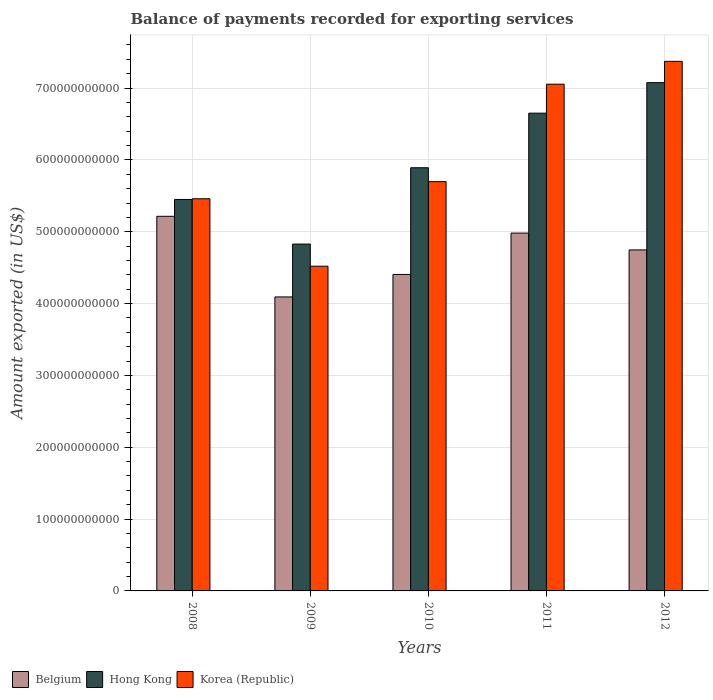How many different coloured bars are there?
Make the answer very short. 3. Are the number of bars on each tick of the X-axis equal?
Your answer should be very brief. Yes. How many bars are there on the 3rd tick from the right?
Give a very brief answer. 3. In how many cases, is the number of bars for a given year not equal to the number of legend labels?
Offer a very short reply. 0. What is the amount exported in Korea (Republic) in 2008?
Your answer should be compact. 5.46e+11. Across all years, what is the maximum amount exported in Belgium?
Provide a short and direct response. 5.21e+11. Across all years, what is the minimum amount exported in Korea (Republic)?
Provide a succinct answer. 4.52e+11. In which year was the amount exported in Belgium maximum?
Offer a terse response. 2008. What is the total amount exported in Korea (Republic) in the graph?
Offer a terse response. 3.01e+12. What is the difference between the amount exported in Hong Kong in 2009 and that in 2010?
Your answer should be compact. -1.06e+11. What is the difference between the amount exported in Hong Kong in 2011 and the amount exported in Korea (Republic) in 2012?
Provide a succinct answer. -7.21e+1. What is the average amount exported in Hong Kong per year?
Your answer should be very brief. 5.98e+11. In the year 2012, what is the difference between the amount exported in Belgium and amount exported in Hong Kong?
Keep it short and to the point. -2.33e+11. What is the ratio of the amount exported in Korea (Republic) in 2008 to that in 2010?
Provide a succinct answer. 0.96. What is the difference between the highest and the second highest amount exported in Korea (Republic)?
Provide a succinct answer. 3.18e+1. What is the difference between the highest and the lowest amount exported in Belgium?
Ensure brevity in your answer.  1.12e+11. What does the 1st bar from the right in 2009 represents?
Your response must be concise. Korea (Republic). Are all the bars in the graph horizontal?
Your answer should be very brief. No. What is the difference between two consecutive major ticks on the Y-axis?
Offer a very short reply. 1.00e+11. Does the graph contain any zero values?
Your answer should be compact. No. Where does the legend appear in the graph?
Ensure brevity in your answer.  Bottom left. What is the title of the graph?
Your answer should be compact. Balance of payments recorded for exporting services. Does "South Asia" appear as one of the legend labels in the graph?
Provide a short and direct response. No. What is the label or title of the Y-axis?
Your answer should be compact. Amount exported (in US$). What is the Amount exported (in US$) of Belgium in 2008?
Your response must be concise. 5.21e+11. What is the Amount exported (in US$) in Hong Kong in 2008?
Offer a very short reply. 5.45e+11. What is the Amount exported (in US$) in Korea (Republic) in 2008?
Make the answer very short. 5.46e+11. What is the Amount exported (in US$) of Belgium in 2009?
Your answer should be very brief. 4.09e+11. What is the Amount exported (in US$) in Hong Kong in 2009?
Provide a succinct answer. 4.83e+11. What is the Amount exported (in US$) in Korea (Republic) in 2009?
Offer a terse response. 4.52e+11. What is the Amount exported (in US$) in Belgium in 2010?
Your response must be concise. 4.41e+11. What is the Amount exported (in US$) of Hong Kong in 2010?
Ensure brevity in your answer.  5.89e+11. What is the Amount exported (in US$) in Korea (Republic) in 2010?
Ensure brevity in your answer.  5.70e+11. What is the Amount exported (in US$) of Belgium in 2011?
Keep it short and to the point. 4.98e+11. What is the Amount exported (in US$) in Hong Kong in 2011?
Your answer should be very brief. 6.65e+11. What is the Amount exported (in US$) in Korea (Republic) in 2011?
Provide a short and direct response. 7.05e+11. What is the Amount exported (in US$) of Belgium in 2012?
Offer a terse response. 4.75e+11. What is the Amount exported (in US$) of Hong Kong in 2012?
Your response must be concise. 7.08e+11. What is the Amount exported (in US$) of Korea (Republic) in 2012?
Provide a succinct answer. 7.37e+11. Across all years, what is the maximum Amount exported (in US$) of Belgium?
Your answer should be compact. 5.21e+11. Across all years, what is the maximum Amount exported (in US$) of Hong Kong?
Provide a short and direct response. 7.08e+11. Across all years, what is the maximum Amount exported (in US$) of Korea (Republic)?
Make the answer very short. 7.37e+11. Across all years, what is the minimum Amount exported (in US$) in Belgium?
Make the answer very short. 4.09e+11. Across all years, what is the minimum Amount exported (in US$) of Hong Kong?
Your answer should be very brief. 4.83e+11. Across all years, what is the minimum Amount exported (in US$) of Korea (Republic)?
Offer a terse response. 4.52e+11. What is the total Amount exported (in US$) of Belgium in the graph?
Give a very brief answer. 2.34e+12. What is the total Amount exported (in US$) in Hong Kong in the graph?
Your answer should be compact. 2.99e+12. What is the total Amount exported (in US$) of Korea (Republic) in the graph?
Offer a terse response. 3.01e+12. What is the difference between the Amount exported (in US$) of Belgium in 2008 and that in 2009?
Your answer should be very brief. 1.12e+11. What is the difference between the Amount exported (in US$) in Hong Kong in 2008 and that in 2009?
Ensure brevity in your answer.  6.21e+1. What is the difference between the Amount exported (in US$) in Korea (Republic) in 2008 and that in 2009?
Your answer should be compact. 9.39e+1. What is the difference between the Amount exported (in US$) of Belgium in 2008 and that in 2010?
Your answer should be compact. 8.09e+1. What is the difference between the Amount exported (in US$) in Hong Kong in 2008 and that in 2010?
Provide a short and direct response. -4.42e+1. What is the difference between the Amount exported (in US$) of Korea (Republic) in 2008 and that in 2010?
Provide a succinct answer. -2.39e+1. What is the difference between the Amount exported (in US$) in Belgium in 2008 and that in 2011?
Provide a short and direct response. 2.33e+1. What is the difference between the Amount exported (in US$) of Hong Kong in 2008 and that in 2011?
Your answer should be very brief. -1.20e+11. What is the difference between the Amount exported (in US$) in Korea (Republic) in 2008 and that in 2011?
Offer a terse response. -1.60e+11. What is the difference between the Amount exported (in US$) in Belgium in 2008 and that in 2012?
Your response must be concise. 4.68e+1. What is the difference between the Amount exported (in US$) in Hong Kong in 2008 and that in 2012?
Keep it short and to the point. -1.63e+11. What is the difference between the Amount exported (in US$) of Korea (Republic) in 2008 and that in 2012?
Your answer should be very brief. -1.91e+11. What is the difference between the Amount exported (in US$) in Belgium in 2009 and that in 2010?
Provide a short and direct response. -3.13e+1. What is the difference between the Amount exported (in US$) of Hong Kong in 2009 and that in 2010?
Provide a succinct answer. -1.06e+11. What is the difference between the Amount exported (in US$) of Korea (Republic) in 2009 and that in 2010?
Offer a very short reply. -1.18e+11. What is the difference between the Amount exported (in US$) of Belgium in 2009 and that in 2011?
Provide a short and direct response. -8.89e+1. What is the difference between the Amount exported (in US$) in Hong Kong in 2009 and that in 2011?
Ensure brevity in your answer.  -1.82e+11. What is the difference between the Amount exported (in US$) of Korea (Republic) in 2009 and that in 2011?
Make the answer very short. -2.53e+11. What is the difference between the Amount exported (in US$) of Belgium in 2009 and that in 2012?
Make the answer very short. -6.54e+1. What is the difference between the Amount exported (in US$) in Hong Kong in 2009 and that in 2012?
Make the answer very short. -2.25e+11. What is the difference between the Amount exported (in US$) of Korea (Republic) in 2009 and that in 2012?
Make the answer very short. -2.85e+11. What is the difference between the Amount exported (in US$) in Belgium in 2010 and that in 2011?
Your answer should be compact. -5.76e+1. What is the difference between the Amount exported (in US$) in Hong Kong in 2010 and that in 2011?
Make the answer very short. -7.60e+1. What is the difference between the Amount exported (in US$) in Korea (Republic) in 2010 and that in 2011?
Ensure brevity in your answer.  -1.36e+11. What is the difference between the Amount exported (in US$) in Belgium in 2010 and that in 2012?
Your answer should be compact. -3.41e+1. What is the difference between the Amount exported (in US$) in Hong Kong in 2010 and that in 2012?
Your answer should be compact. -1.18e+11. What is the difference between the Amount exported (in US$) of Korea (Republic) in 2010 and that in 2012?
Offer a very short reply. -1.67e+11. What is the difference between the Amount exported (in US$) of Belgium in 2011 and that in 2012?
Ensure brevity in your answer.  2.34e+1. What is the difference between the Amount exported (in US$) in Hong Kong in 2011 and that in 2012?
Make the answer very short. -4.25e+1. What is the difference between the Amount exported (in US$) in Korea (Republic) in 2011 and that in 2012?
Provide a short and direct response. -3.18e+1. What is the difference between the Amount exported (in US$) of Belgium in 2008 and the Amount exported (in US$) of Hong Kong in 2009?
Provide a succinct answer. 3.86e+1. What is the difference between the Amount exported (in US$) of Belgium in 2008 and the Amount exported (in US$) of Korea (Republic) in 2009?
Ensure brevity in your answer.  6.95e+1. What is the difference between the Amount exported (in US$) of Hong Kong in 2008 and the Amount exported (in US$) of Korea (Republic) in 2009?
Make the answer very short. 9.29e+1. What is the difference between the Amount exported (in US$) in Belgium in 2008 and the Amount exported (in US$) in Hong Kong in 2010?
Offer a very short reply. -6.76e+1. What is the difference between the Amount exported (in US$) in Belgium in 2008 and the Amount exported (in US$) in Korea (Republic) in 2010?
Provide a short and direct response. -4.83e+1. What is the difference between the Amount exported (in US$) of Hong Kong in 2008 and the Amount exported (in US$) of Korea (Republic) in 2010?
Provide a succinct answer. -2.48e+1. What is the difference between the Amount exported (in US$) in Belgium in 2008 and the Amount exported (in US$) in Hong Kong in 2011?
Make the answer very short. -1.44e+11. What is the difference between the Amount exported (in US$) in Belgium in 2008 and the Amount exported (in US$) in Korea (Republic) in 2011?
Your response must be concise. -1.84e+11. What is the difference between the Amount exported (in US$) in Hong Kong in 2008 and the Amount exported (in US$) in Korea (Republic) in 2011?
Keep it short and to the point. -1.60e+11. What is the difference between the Amount exported (in US$) of Belgium in 2008 and the Amount exported (in US$) of Hong Kong in 2012?
Offer a terse response. -1.86e+11. What is the difference between the Amount exported (in US$) of Belgium in 2008 and the Amount exported (in US$) of Korea (Republic) in 2012?
Your answer should be compact. -2.16e+11. What is the difference between the Amount exported (in US$) in Hong Kong in 2008 and the Amount exported (in US$) in Korea (Republic) in 2012?
Your answer should be compact. -1.92e+11. What is the difference between the Amount exported (in US$) in Belgium in 2009 and the Amount exported (in US$) in Hong Kong in 2010?
Give a very brief answer. -1.80e+11. What is the difference between the Amount exported (in US$) of Belgium in 2009 and the Amount exported (in US$) of Korea (Republic) in 2010?
Your response must be concise. -1.61e+11. What is the difference between the Amount exported (in US$) of Hong Kong in 2009 and the Amount exported (in US$) of Korea (Republic) in 2010?
Provide a succinct answer. -8.69e+1. What is the difference between the Amount exported (in US$) of Belgium in 2009 and the Amount exported (in US$) of Hong Kong in 2011?
Provide a short and direct response. -2.56e+11. What is the difference between the Amount exported (in US$) of Belgium in 2009 and the Amount exported (in US$) of Korea (Republic) in 2011?
Make the answer very short. -2.96e+11. What is the difference between the Amount exported (in US$) of Hong Kong in 2009 and the Amount exported (in US$) of Korea (Republic) in 2011?
Give a very brief answer. -2.23e+11. What is the difference between the Amount exported (in US$) in Belgium in 2009 and the Amount exported (in US$) in Hong Kong in 2012?
Your response must be concise. -2.98e+11. What is the difference between the Amount exported (in US$) in Belgium in 2009 and the Amount exported (in US$) in Korea (Republic) in 2012?
Your answer should be compact. -3.28e+11. What is the difference between the Amount exported (in US$) in Hong Kong in 2009 and the Amount exported (in US$) in Korea (Republic) in 2012?
Give a very brief answer. -2.54e+11. What is the difference between the Amount exported (in US$) in Belgium in 2010 and the Amount exported (in US$) in Hong Kong in 2011?
Offer a terse response. -2.24e+11. What is the difference between the Amount exported (in US$) in Belgium in 2010 and the Amount exported (in US$) in Korea (Republic) in 2011?
Give a very brief answer. -2.65e+11. What is the difference between the Amount exported (in US$) of Hong Kong in 2010 and the Amount exported (in US$) of Korea (Republic) in 2011?
Provide a succinct answer. -1.16e+11. What is the difference between the Amount exported (in US$) in Belgium in 2010 and the Amount exported (in US$) in Hong Kong in 2012?
Make the answer very short. -2.67e+11. What is the difference between the Amount exported (in US$) of Belgium in 2010 and the Amount exported (in US$) of Korea (Republic) in 2012?
Offer a very short reply. -2.97e+11. What is the difference between the Amount exported (in US$) of Hong Kong in 2010 and the Amount exported (in US$) of Korea (Republic) in 2012?
Your response must be concise. -1.48e+11. What is the difference between the Amount exported (in US$) in Belgium in 2011 and the Amount exported (in US$) in Hong Kong in 2012?
Ensure brevity in your answer.  -2.09e+11. What is the difference between the Amount exported (in US$) in Belgium in 2011 and the Amount exported (in US$) in Korea (Republic) in 2012?
Your response must be concise. -2.39e+11. What is the difference between the Amount exported (in US$) in Hong Kong in 2011 and the Amount exported (in US$) in Korea (Republic) in 2012?
Keep it short and to the point. -7.21e+1. What is the average Amount exported (in US$) of Belgium per year?
Ensure brevity in your answer.  4.69e+11. What is the average Amount exported (in US$) of Hong Kong per year?
Your answer should be compact. 5.98e+11. What is the average Amount exported (in US$) in Korea (Republic) per year?
Your answer should be compact. 6.02e+11. In the year 2008, what is the difference between the Amount exported (in US$) in Belgium and Amount exported (in US$) in Hong Kong?
Keep it short and to the point. -2.35e+1. In the year 2008, what is the difference between the Amount exported (in US$) of Belgium and Amount exported (in US$) of Korea (Republic)?
Offer a terse response. -2.44e+1. In the year 2008, what is the difference between the Amount exported (in US$) in Hong Kong and Amount exported (in US$) in Korea (Republic)?
Offer a very short reply. -9.65e+08. In the year 2009, what is the difference between the Amount exported (in US$) in Belgium and Amount exported (in US$) in Hong Kong?
Keep it short and to the point. -7.36e+1. In the year 2009, what is the difference between the Amount exported (in US$) of Belgium and Amount exported (in US$) of Korea (Republic)?
Your answer should be very brief. -4.28e+1. In the year 2009, what is the difference between the Amount exported (in US$) in Hong Kong and Amount exported (in US$) in Korea (Republic)?
Give a very brief answer. 3.08e+1. In the year 2010, what is the difference between the Amount exported (in US$) of Belgium and Amount exported (in US$) of Hong Kong?
Keep it short and to the point. -1.49e+11. In the year 2010, what is the difference between the Amount exported (in US$) in Belgium and Amount exported (in US$) in Korea (Republic)?
Your answer should be compact. -1.29e+11. In the year 2010, what is the difference between the Amount exported (in US$) in Hong Kong and Amount exported (in US$) in Korea (Republic)?
Keep it short and to the point. 1.93e+1. In the year 2011, what is the difference between the Amount exported (in US$) in Belgium and Amount exported (in US$) in Hong Kong?
Your answer should be compact. -1.67e+11. In the year 2011, what is the difference between the Amount exported (in US$) of Belgium and Amount exported (in US$) of Korea (Republic)?
Your response must be concise. -2.07e+11. In the year 2011, what is the difference between the Amount exported (in US$) of Hong Kong and Amount exported (in US$) of Korea (Republic)?
Make the answer very short. -4.04e+1. In the year 2012, what is the difference between the Amount exported (in US$) in Belgium and Amount exported (in US$) in Hong Kong?
Provide a succinct answer. -2.33e+11. In the year 2012, what is the difference between the Amount exported (in US$) of Belgium and Amount exported (in US$) of Korea (Republic)?
Make the answer very short. -2.62e+11. In the year 2012, what is the difference between the Amount exported (in US$) of Hong Kong and Amount exported (in US$) of Korea (Republic)?
Make the answer very short. -2.96e+1. What is the ratio of the Amount exported (in US$) in Belgium in 2008 to that in 2009?
Offer a terse response. 1.27. What is the ratio of the Amount exported (in US$) of Hong Kong in 2008 to that in 2009?
Keep it short and to the point. 1.13. What is the ratio of the Amount exported (in US$) in Korea (Republic) in 2008 to that in 2009?
Offer a very short reply. 1.21. What is the ratio of the Amount exported (in US$) in Belgium in 2008 to that in 2010?
Your answer should be compact. 1.18. What is the ratio of the Amount exported (in US$) in Hong Kong in 2008 to that in 2010?
Your response must be concise. 0.93. What is the ratio of the Amount exported (in US$) of Korea (Republic) in 2008 to that in 2010?
Ensure brevity in your answer.  0.96. What is the ratio of the Amount exported (in US$) in Belgium in 2008 to that in 2011?
Keep it short and to the point. 1.05. What is the ratio of the Amount exported (in US$) of Hong Kong in 2008 to that in 2011?
Give a very brief answer. 0.82. What is the ratio of the Amount exported (in US$) in Korea (Republic) in 2008 to that in 2011?
Your answer should be compact. 0.77. What is the ratio of the Amount exported (in US$) of Belgium in 2008 to that in 2012?
Your response must be concise. 1.1. What is the ratio of the Amount exported (in US$) of Hong Kong in 2008 to that in 2012?
Offer a terse response. 0.77. What is the ratio of the Amount exported (in US$) in Korea (Republic) in 2008 to that in 2012?
Offer a very short reply. 0.74. What is the ratio of the Amount exported (in US$) in Belgium in 2009 to that in 2010?
Make the answer very short. 0.93. What is the ratio of the Amount exported (in US$) in Hong Kong in 2009 to that in 2010?
Make the answer very short. 0.82. What is the ratio of the Amount exported (in US$) in Korea (Republic) in 2009 to that in 2010?
Your answer should be very brief. 0.79. What is the ratio of the Amount exported (in US$) in Belgium in 2009 to that in 2011?
Your answer should be very brief. 0.82. What is the ratio of the Amount exported (in US$) in Hong Kong in 2009 to that in 2011?
Make the answer very short. 0.73. What is the ratio of the Amount exported (in US$) in Korea (Republic) in 2009 to that in 2011?
Offer a very short reply. 0.64. What is the ratio of the Amount exported (in US$) of Belgium in 2009 to that in 2012?
Your answer should be compact. 0.86. What is the ratio of the Amount exported (in US$) of Hong Kong in 2009 to that in 2012?
Offer a terse response. 0.68. What is the ratio of the Amount exported (in US$) of Korea (Republic) in 2009 to that in 2012?
Keep it short and to the point. 0.61. What is the ratio of the Amount exported (in US$) of Belgium in 2010 to that in 2011?
Your answer should be compact. 0.88. What is the ratio of the Amount exported (in US$) in Hong Kong in 2010 to that in 2011?
Give a very brief answer. 0.89. What is the ratio of the Amount exported (in US$) of Korea (Republic) in 2010 to that in 2011?
Make the answer very short. 0.81. What is the ratio of the Amount exported (in US$) in Belgium in 2010 to that in 2012?
Make the answer very short. 0.93. What is the ratio of the Amount exported (in US$) in Hong Kong in 2010 to that in 2012?
Provide a short and direct response. 0.83. What is the ratio of the Amount exported (in US$) of Korea (Republic) in 2010 to that in 2012?
Offer a terse response. 0.77. What is the ratio of the Amount exported (in US$) in Belgium in 2011 to that in 2012?
Make the answer very short. 1.05. What is the ratio of the Amount exported (in US$) in Hong Kong in 2011 to that in 2012?
Your response must be concise. 0.94. What is the ratio of the Amount exported (in US$) in Korea (Republic) in 2011 to that in 2012?
Provide a succinct answer. 0.96. What is the difference between the highest and the second highest Amount exported (in US$) of Belgium?
Give a very brief answer. 2.33e+1. What is the difference between the highest and the second highest Amount exported (in US$) in Hong Kong?
Offer a very short reply. 4.25e+1. What is the difference between the highest and the second highest Amount exported (in US$) in Korea (Republic)?
Give a very brief answer. 3.18e+1. What is the difference between the highest and the lowest Amount exported (in US$) in Belgium?
Ensure brevity in your answer.  1.12e+11. What is the difference between the highest and the lowest Amount exported (in US$) in Hong Kong?
Give a very brief answer. 2.25e+11. What is the difference between the highest and the lowest Amount exported (in US$) in Korea (Republic)?
Give a very brief answer. 2.85e+11. 